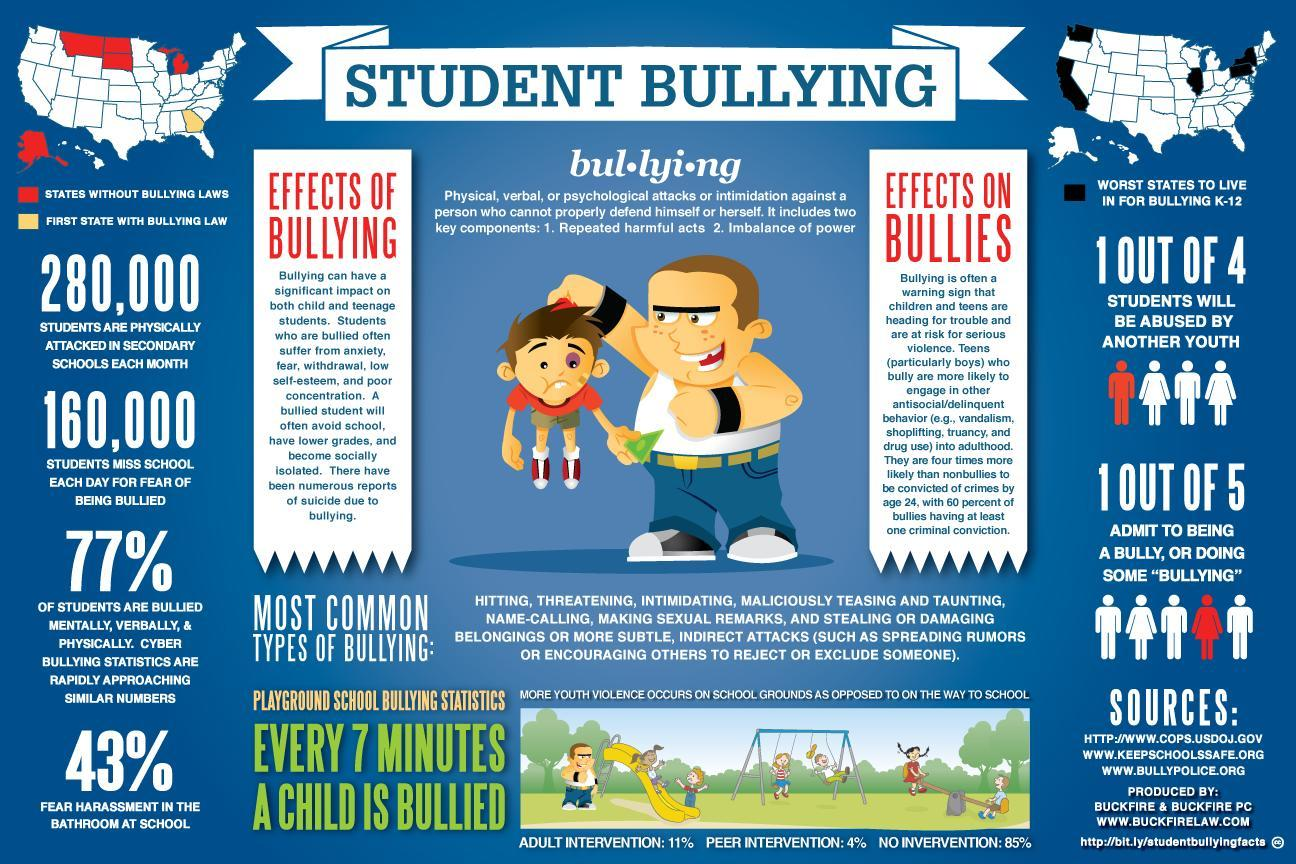What percentage of students in America fear harassment in the bathroom at school?
Answer the question with a short phrase. 43% How many students miss school each day for the fear of being cyber bullied in America? 160,000 Which is the first state in the U.S passing the bullying laws - Alaska, California, Georgia or Texas? Georgia How many students are physically attacked in secondary schools each month in America? 280,000 